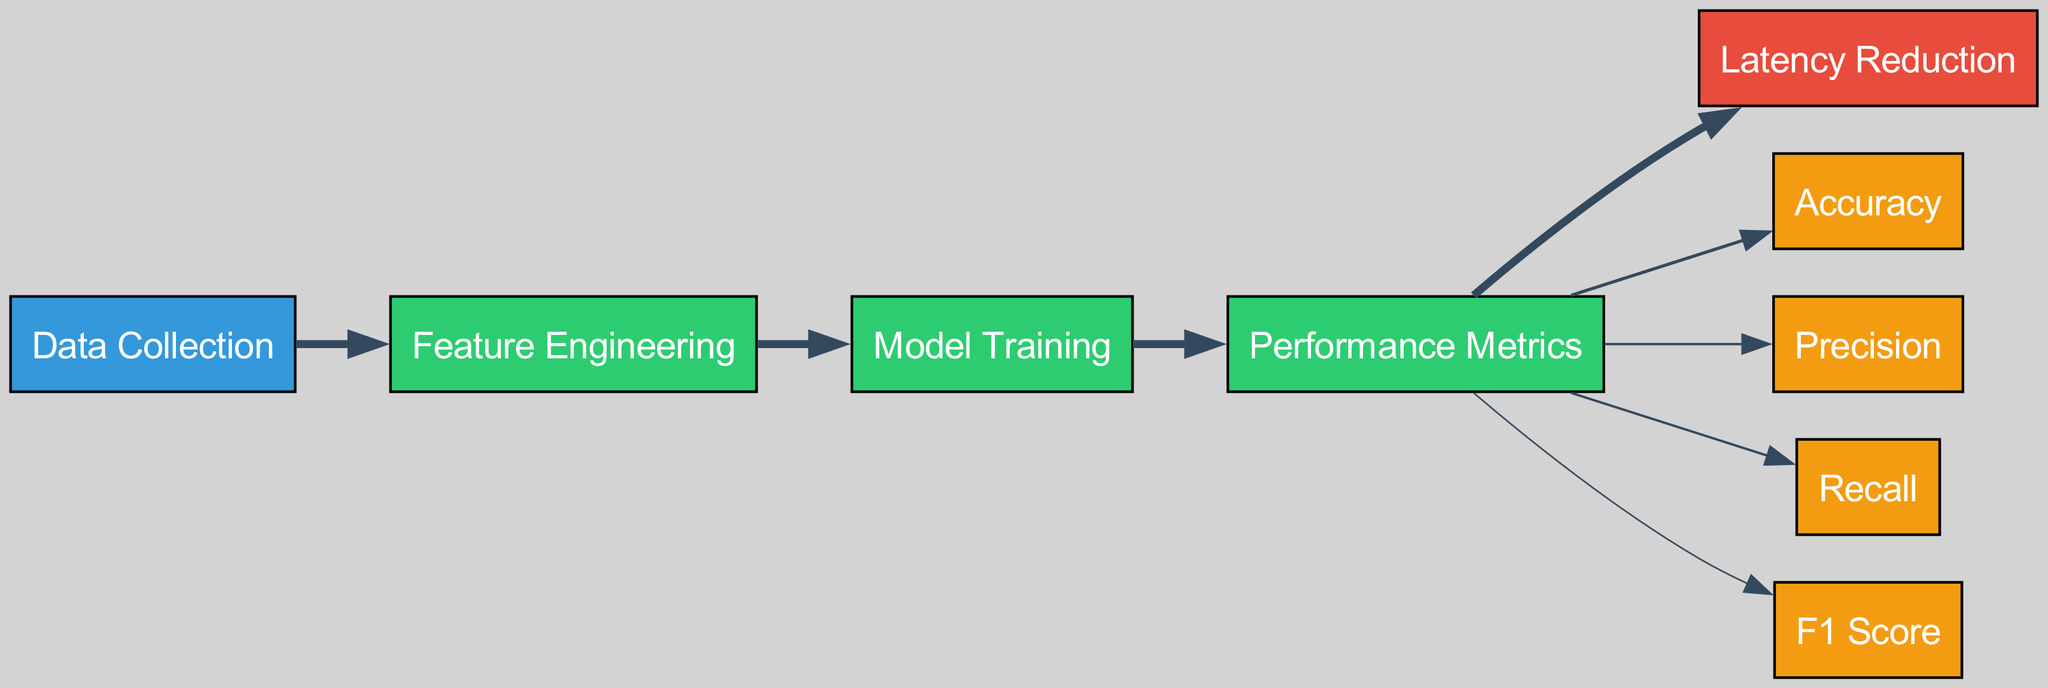What are the types of nodes present in the diagram? The diagram consists of four types of nodes: source, process, outcome, and metric. Each node type serves a specific role in the machine learning model performance metrics workflow.
Answer: source, process, outcome, metric How many performance metrics are included in the diagram? There are four performance metrics in the diagram: Accuracy, Precision, Recall, and F1 Score. Each has a distinct connection to the Performance Metrics node.
Answer: four What is the total flow value from Performance Metrics to Latency Reduction? The value of the flow from Performance Metrics to Latency Reduction is 1. This indicates that there is a direct and singular contribution from the Performance Metrics node to Latency Reduction.
Answer: 1 Which metric has the highest flow value? The metric with the highest flow value is Accuracy, with a flow value of 0.4. This shows that Accuracy is considered the most significant metric in measuring performance for this context.
Answer: Accuracy How many nodes are directly connected to the Performance Metrics node? There are four nodes directly connected to the Performance Metrics node: Accuracy, Precision, Recall, and F1 Score, each illustrating the different aspects of model performance.
Answer: four What is the flow value from Model Training to Performance Metrics? The flow value from Model Training to Performance Metrics is 1. This indicates that there is a single, substantial transition from Model Training to the assessment phase of performance metrics.
Answer: 1 Which node comes first in the workflow before reaching Latency Reduction? The initial node in the workflow before reaching Latency Reduction is Data Collection. This indicates the first step in the process of enhancing network latency through machine learning.
Answer: Data Collection Which two processes directly link to Performance Metrics? The two processes that directly link to Performance Metrics are Model Training and Feature Engineering. These two processes contribute to the evaluation of performance metrics.
Answer: Model Training, Feature Engineering What is the flow value from Performance Metrics to Recall? The flow value from Performance Metrics to Recall is 0.3. This indicates the quantitative importance or contribution of Recall as a performance metric related to network latency improvement.
Answer: 0.3 